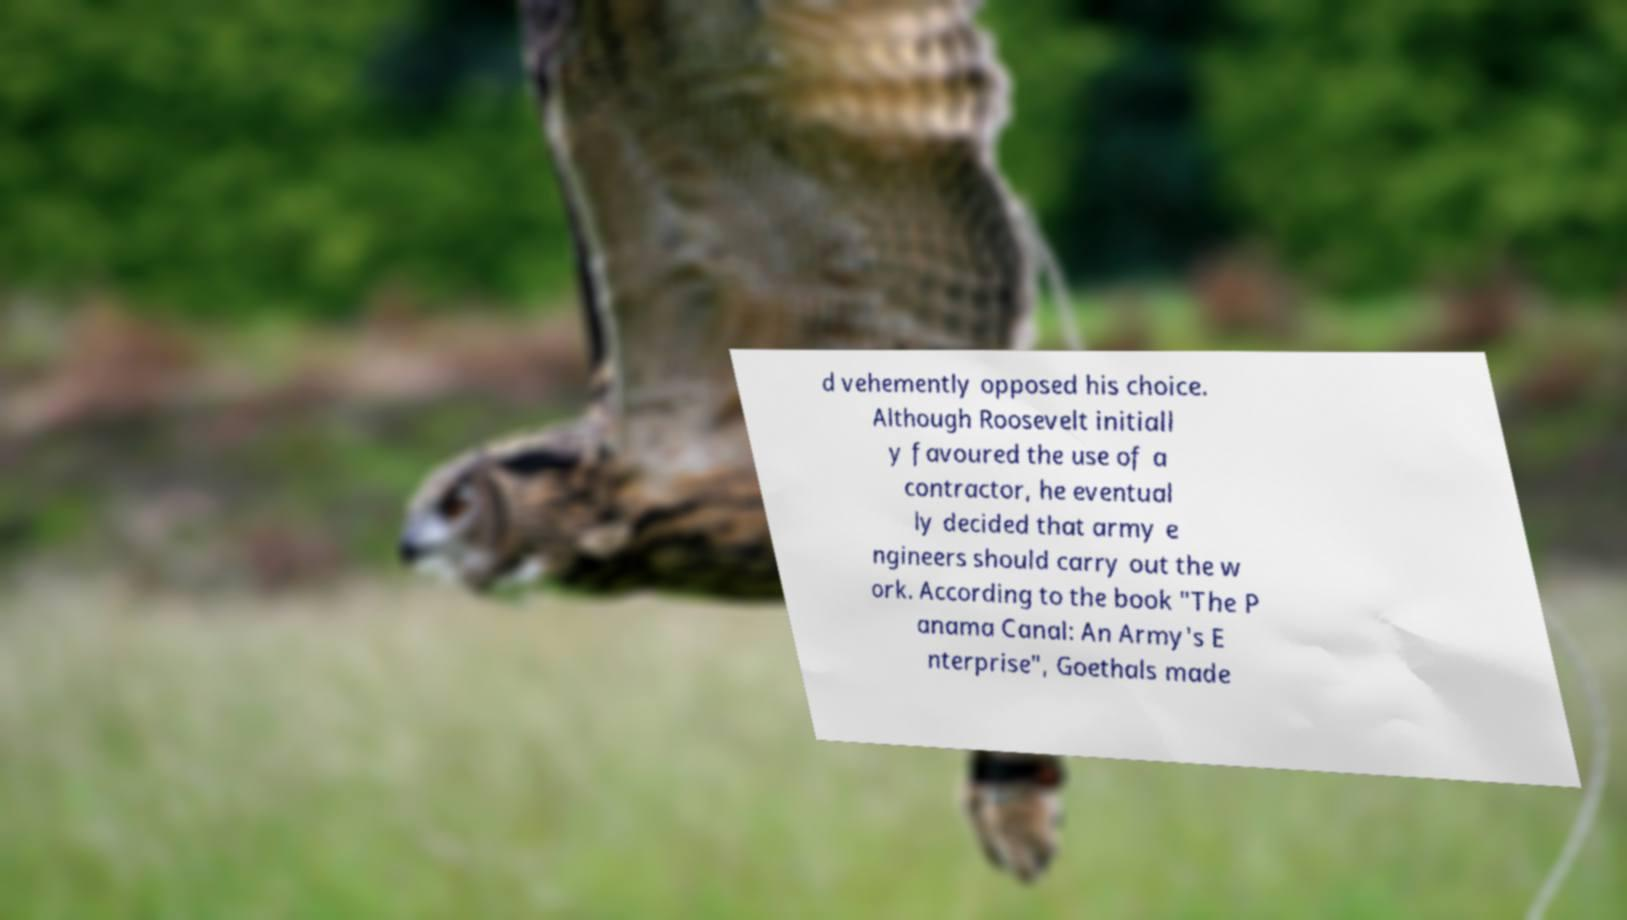There's text embedded in this image that I need extracted. Can you transcribe it verbatim? d vehemently opposed his choice. Although Roosevelt initiall y favoured the use of a contractor, he eventual ly decided that army e ngineers should carry out the w ork. According to the book "The P anama Canal: An Army's E nterprise", Goethals made 